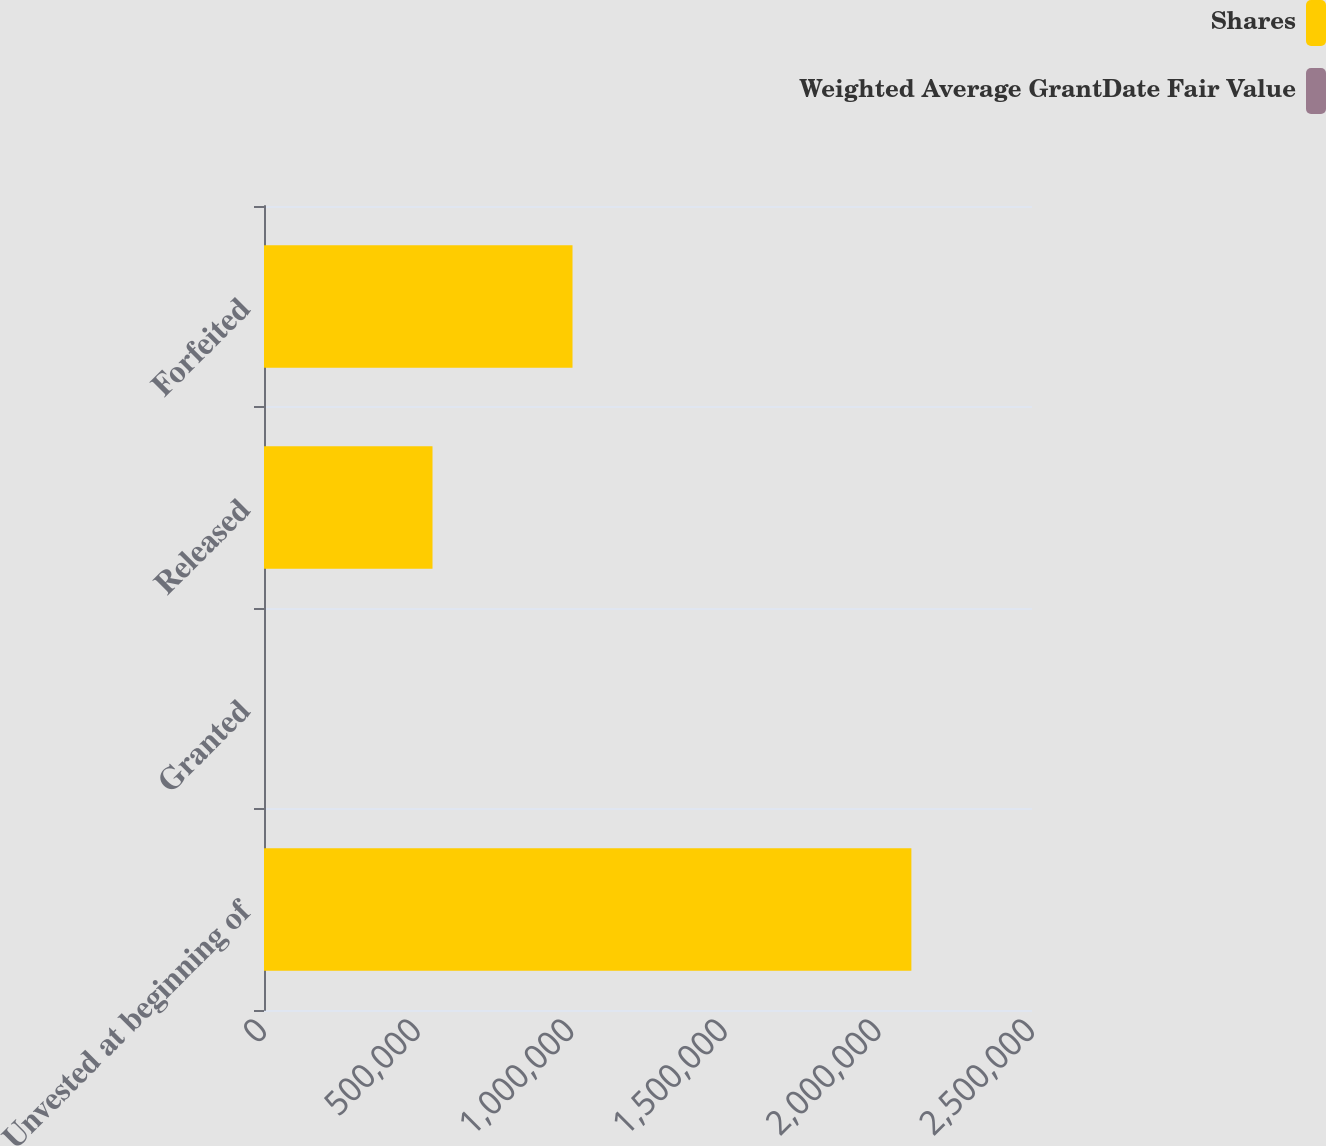<chart> <loc_0><loc_0><loc_500><loc_500><stacked_bar_chart><ecel><fcel>Unvested at beginning of<fcel>Granted<fcel>Released<fcel>Forfeited<nl><fcel>Shares<fcel>2.10733e+06<fcel>29.23<fcel>548510<fcel>1.00423e+06<nl><fcel>Weighted Average GrantDate Fair Value<fcel>20.01<fcel>29.23<fcel>22<fcel>22.98<nl></chart> 